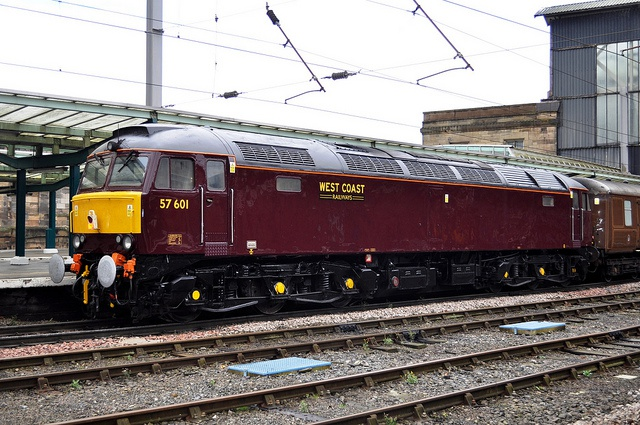Describe the objects in this image and their specific colors. I can see a train in white, black, maroon, gray, and darkgray tones in this image. 